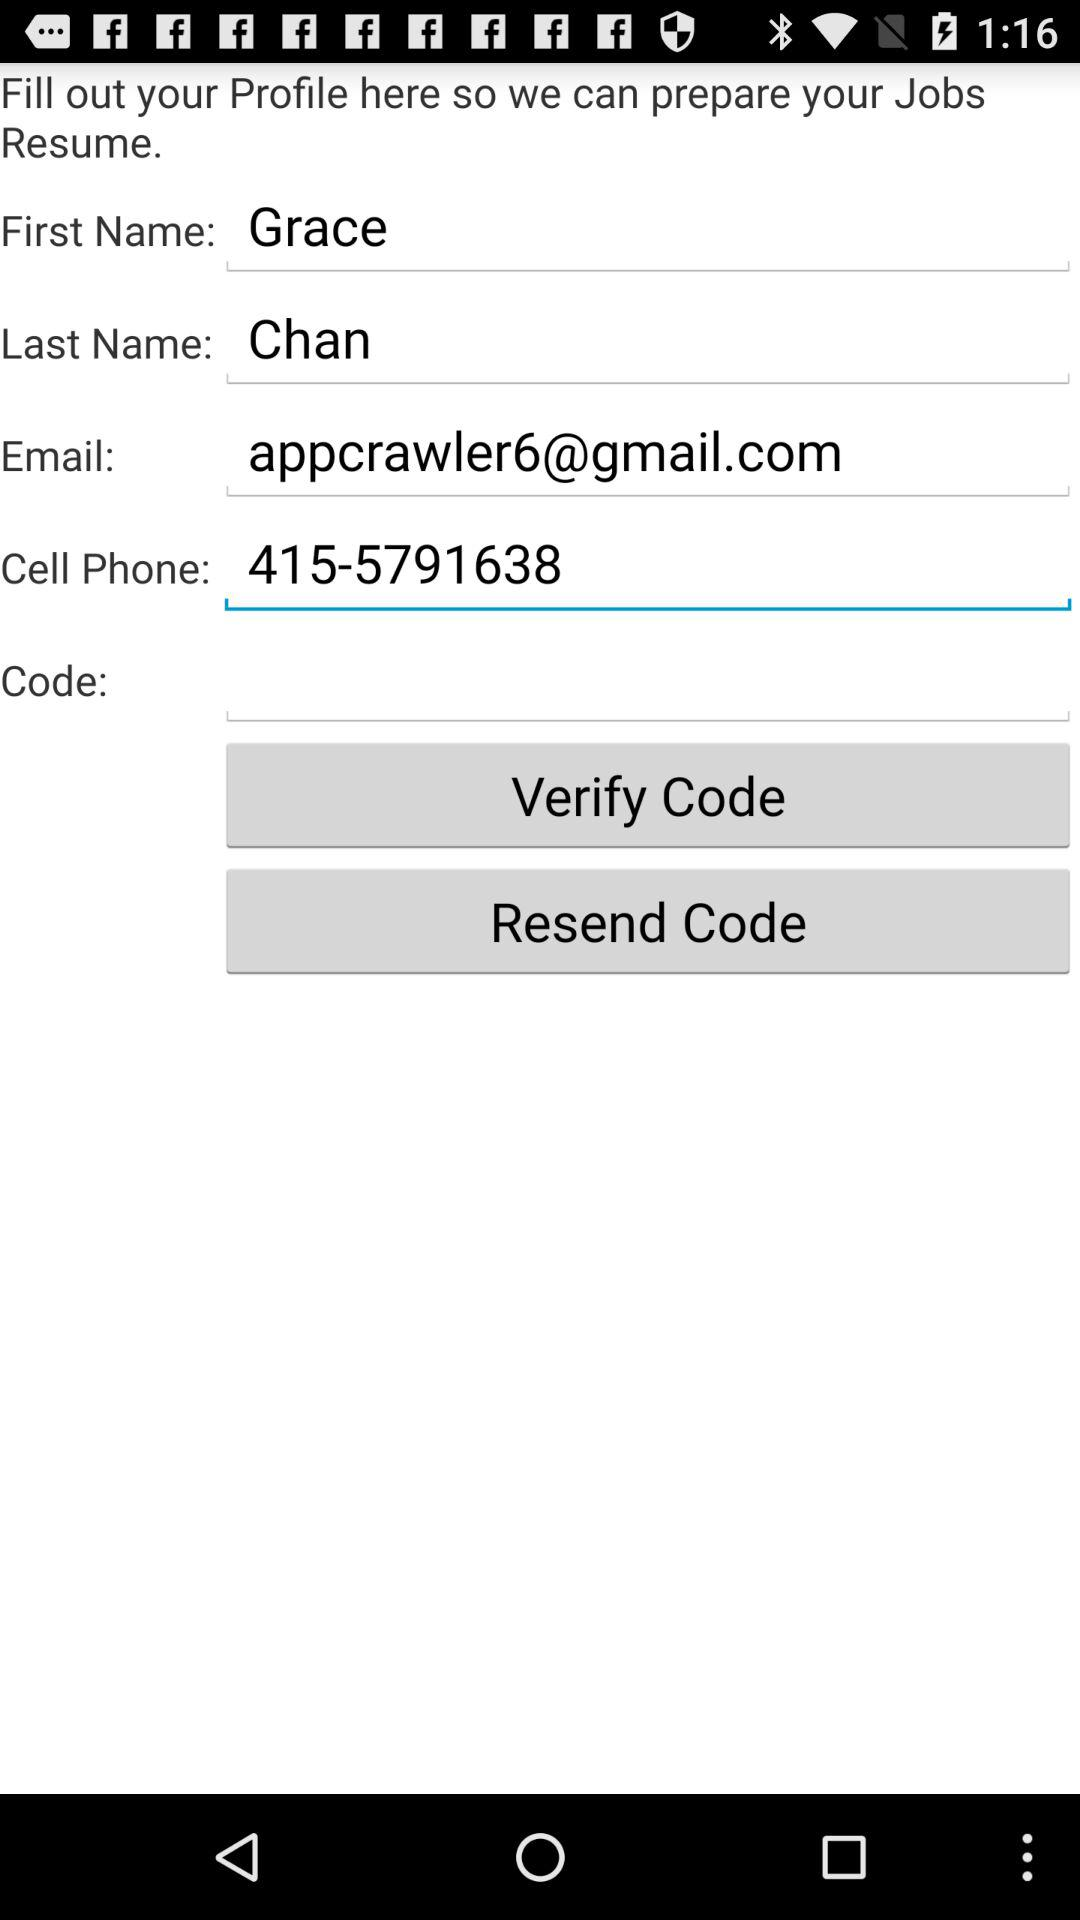What's the cell phone number? The cell phone number is 415-5791638. 